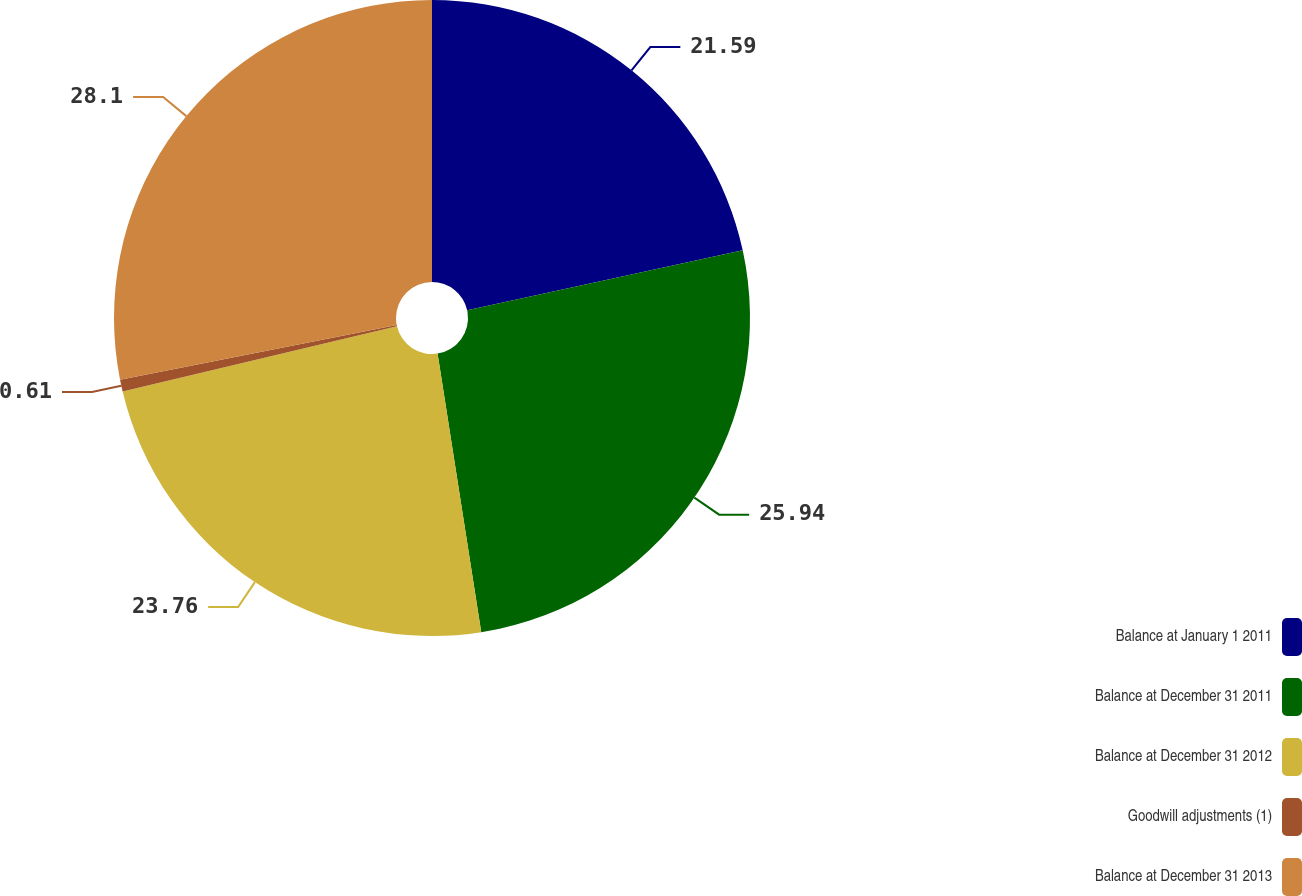<chart> <loc_0><loc_0><loc_500><loc_500><pie_chart><fcel>Balance at January 1 2011<fcel>Balance at December 31 2011<fcel>Balance at December 31 2012<fcel>Goodwill adjustments (1)<fcel>Balance at December 31 2013<nl><fcel>21.59%<fcel>25.94%<fcel>23.76%<fcel>0.61%<fcel>28.11%<nl></chart> 